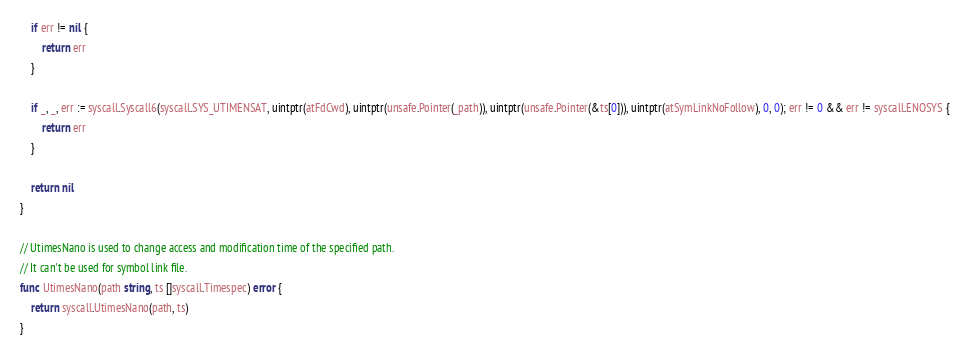Convert code to text. <code><loc_0><loc_0><loc_500><loc_500><_Go_>	if err != nil {
		return err
	}

	if _, _, err := syscall.Syscall6(syscall.SYS_UTIMENSAT, uintptr(atFdCwd), uintptr(unsafe.Pointer(_path)), uintptr(unsafe.Pointer(&ts[0])), uintptr(atSymLinkNoFollow), 0, 0); err != 0 && err != syscall.ENOSYS {
		return err
	}

	return nil
}

// UtimesNano is used to change access and modification time of the specified path.
// It can't be used for symbol link file.
func UtimesNano(path string, ts []syscall.Timespec) error {
	return syscall.UtimesNano(path, ts)
}
</code> 